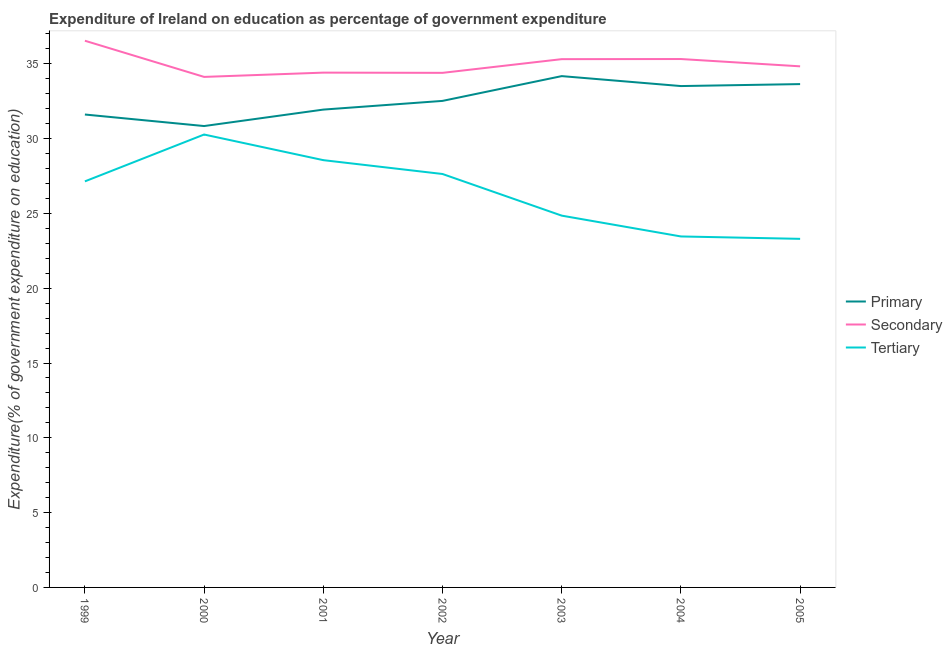Does the line corresponding to expenditure on secondary education intersect with the line corresponding to expenditure on primary education?
Provide a succinct answer. No. What is the expenditure on primary education in 2005?
Ensure brevity in your answer.  33.65. Across all years, what is the maximum expenditure on secondary education?
Offer a terse response. 36.54. Across all years, what is the minimum expenditure on primary education?
Offer a terse response. 30.84. In which year was the expenditure on primary education minimum?
Offer a terse response. 2000. What is the total expenditure on tertiary education in the graph?
Provide a succinct answer. 185.23. What is the difference between the expenditure on tertiary education in 1999 and that in 2004?
Ensure brevity in your answer.  3.68. What is the difference between the expenditure on secondary education in 2004 and the expenditure on tertiary education in 2001?
Your answer should be compact. 6.76. What is the average expenditure on primary education per year?
Provide a short and direct response. 32.61. In the year 2003, what is the difference between the expenditure on secondary education and expenditure on tertiary education?
Keep it short and to the point. 10.46. In how many years, is the expenditure on primary education greater than 11 %?
Provide a succinct answer. 7. What is the ratio of the expenditure on primary education in 2001 to that in 2004?
Ensure brevity in your answer.  0.95. Is the expenditure on secondary education in 2000 less than that in 2002?
Make the answer very short. Yes. Is the difference between the expenditure on tertiary education in 1999 and 2001 greater than the difference between the expenditure on primary education in 1999 and 2001?
Offer a very short reply. No. What is the difference between the highest and the second highest expenditure on primary education?
Offer a terse response. 0.53. What is the difference between the highest and the lowest expenditure on secondary education?
Your response must be concise. 2.42. Is the sum of the expenditure on primary education in 2000 and 2004 greater than the maximum expenditure on tertiary education across all years?
Your answer should be compact. Yes. How many lines are there?
Your answer should be compact. 3. What is the difference between two consecutive major ticks on the Y-axis?
Ensure brevity in your answer.  5. Where does the legend appear in the graph?
Provide a short and direct response. Center right. How are the legend labels stacked?
Ensure brevity in your answer.  Vertical. What is the title of the graph?
Your response must be concise. Expenditure of Ireland on education as percentage of government expenditure. Does "Ages 0-14" appear as one of the legend labels in the graph?
Your response must be concise. No. What is the label or title of the X-axis?
Offer a very short reply. Year. What is the label or title of the Y-axis?
Provide a short and direct response. Expenditure(% of government expenditure on education). What is the Expenditure(% of government expenditure on education) in Primary in 1999?
Offer a very short reply. 31.61. What is the Expenditure(% of government expenditure on education) of Secondary in 1999?
Keep it short and to the point. 36.54. What is the Expenditure(% of government expenditure on education) in Tertiary in 1999?
Provide a succinct answer. 27.14. What is the Expenditure(% of government expenditure on education) in Primary in 2000?
Ensure brevity in your answer.  30.84. What is the Expenditure(% of government expenditure on education) of Secondary in 2000?
Your answer should be compact. 34.13. What is the Expenditure(% of government expenditure on education) in Tertiary in 2000?
Your answer should be very brief. 30.27. What is the Expenditure(% of government expenditure on education) of Primary in 2001?
Offer a very short reply. 31.94. What is the Expenditure(% of government expenditure on education) in Secondary in 2001?
Your answer should be very brief. 34.41. What is the Expenditure(% of government expenditure on education) in Tertiary in 2001?
Ensure brevity in your answer.  28.56. What is the Expenditure(% of government expenditure on education) in Primary in 2002?
Make the answer very short. 32.52. What is the Expenditure(% of government expenditure on education) of Secondary in 2002?
Your answer should be very brief. 34.4. What is the Expenditure(% of government expenditure on education) of Tertiary in 2002?
Give a very brief answer. 27.64. What is the Expenditure(% of government expenditure on education) in Primary in 2003?
Keep it short and to the point. 34.18. What is the Expenditure(% of government expenditure on education) of Secondary in 2003?
Give a very brief answer. 35.31. What is the Expenditure(% of government expenditure on education) in Tertiary in 2003?
Provide a short and direct response. 24.85. What is the Expenditure(% of government expenditure on education) of Primary in 2004?
Offer a very short reply. 33.51. What is the Expenditure(% of government expenditure on education) of Secondary in 2004?
Offer a terse response. 35.32. What is the Expenditure(% of government expenditure on education) in Tertiary in 2004?
Provide a succinct answer. 23.46. What is the Expenditure(% of government expenditure on education) in Primary in 2005?
Keep it short and to the point. 33.65. What is the Expenditure(% of government expenditure on education) of Secondary in 2005?
Offer a very short reply. 34.83. What is the Expenditure(% of government expenditure on education) of Tertiary in 2005?
Provide a succinct answer. 23.3. Across all years, what is the maximum Expenditure(% of government expenditure on education) of Primary?
Your answer should be very brief. 34.18. Across all years, what is the maximum Expenditure(% of government expenditure on education) of Secondary?
Provide a succinct answer. 36.54. Across all years, what is the maximum Expenditure(% of government expenditure on education) of Tertiary?
Keep it short and to the point. 30.27. Across all years, what is the minimum Expenditure(% of government expenditure on education) in Primary?
Offer a terse response. 30.84. Across all years, what is the minimum Expenditure(% of government expenditure on education) of Secondary?
Provide a succinct answer. 34.13. Across all years, what is the minimum Expenditure(% of government expenditure on education) in Tertiary?
Offer a very short reply. 23.3. What is the total Expenditure(% of government expenditure on education) of Primary in the graph?
Offer a terse response. 228.25. What is the total Expenditure(% of government expenditure on education) of Secondary in the graph?
Give a very brief answer. 244.95. What is the total Expenditure(% of government expenditure on education) of Tertiary in the graph?
Your answer should be very brief. 185.23. What is the difference between the Expenditure(% of government expenditure on education) of Primary in 1999 and that in 2000?
Provide a short and direct response. 0.77. What is the difference between the Expenditure(% of government expenditure on education) in Secondary in 1999 and that in 2000?
Your response must be concise. 2.42. What is the difference between the Expenditure(% of government expenditure on education) in Tertiary in 1999 and that in 2000?
Offer a very short reply. -3.13. What is the difference between the Expenditure(% of government expenditure on education) of Primary in 1999 and that in 2001?
Offer a very short reply. -0.33. What is the difference between the Expenditure(% of government expenditure on education) in Secondary in 1999 and that in 2001?
Offer a very short reply. 2.13. What is the difference between the Expenditure(% of government expenditure on education) in Tertiary in 1999 and that in 2001?
Your answer should be compact. -1.42. What is the difference between the Expenditure(% of government expenditure on education) of Primary in 1999 and that in 2002?
Make the answer very short. -0.91. What is the difference between the Expenditure(% of government expenditure on education) in Secondary in 1999 and that in 2002?
Your answer should be compact. 2.15. What is the difference between the Expenditure(% of government expenditure on education) of Tertiary in 1999 and that in 2002?
Your answer should be very brief. -0.49. What is the difference between the Expenditure(% of government expenditure on education) of Primary in 1999 and that in 2003?
Ensure brevity in your answer.  -2.57. What is the difference between the Expenditure(% of government expenditure on education) of Secondary in 1999 and that in 2003?
Ensure brevity in your answer.  1.23. What is the difference between the Expenditure(% of government expenditure on education) in Tertiary in 1999 and that in 2003?
Your answer should be compact. 2.29. What is the difference between the Expenditure(% of government expenditure on education) of Primary in 1999 and that in 2004?
Provide a short and direct response. -1.9. What is the difference between the Expenditure(% of government expenditure on education) of Secondary in 1999 and that in 2004?
Your answer should be very brief. 1.22. What is the difference between the Expenditure(% of government expenditure on education) in Tertiary in 1999 and that in 2004?
Provide a succinct answer. 3.68. What is the difference between the Expenditure(% of government expenditure on education) of Primary in 1999 and that in 2005?
Make the answer very short. -2.03. What is the difference between the Expenditure(% of government expenditure on education) in Secondary in 1999 and that in 2005?
Ensure brevity in your answer.  1.71. What is the difference between the Expenditure(% of government expenditure on education) in Tertiary in 1999 and that in 2005?
Keep it short and to the point. 3.84. What is the difference between the Expenditure(% of government expenditure on education) of Primary in 2000 and that in 2001?
Ensure brevity in your answer.  -1.1. What is the difference between the Expenditure(% of government expenditure on education) of Secondary in 2000 and that in 2001?
Provide a short and direct response. -0.29. What is the difference between the Expenditure(% of government expenditure on education) in Tertiary in 2000 and that in 2001?
Make the answer very short. 1.71. What is the difference between the Expenditure(% of government expenditure on education) of Primary in 2000 and that in 2002?
Provide a succinct answer. -1.68. What is the difference between the Expenditure(% of government expenditure on education) in Secondary in 2000 and that in 2002?
Offer a very short reply. -0.27. What is the difference between the Expenditure(% of government expenditure on education) in Tertiary in 2000 and that in 2002?
Give a very brief answer. 2.64. What is the difference between the Expenditure(% of government expenditure on education) in Primary in 2000 and that in 2003?
Ensure brevity in your answer.  -3.34. What is the difference between the Expenditure(% of government expenditure on education) in Secondary in 2000 and that in 2003?
Make the answer very short. -1.19. What is the difference between the Expenditure(% of government expenditure on education) of Tertiary in 2000 and that in 2003?
Provide a succinct answer. 5.42. What is the difference between the Expenditure(% of government expenditure on education) in Primary in 2000 and that in 2004?
Make the answer very short. -2.67. What is the difference between the Expenditure(% of government expenditure on education) of Secondary in 2000 and that in 2004?
Offer a very short reply. -1.19. What is the difference between the Expenditure(% of government expenditure on education) of Tertiary in 2000 and that in 2004?
Provide a succinct answer. 6.81. What is the difference between the Expenditure(% of government expenditure on education) of Primary in 2000 and that in 2005?
Keep it short and to the point. -2.81. What is the difference between the Expenditure(% of government expenditure on education) in Secondary in 2000 and that in 2005?
Keep it short and to the point. -0.71. What is the difference between the Expenditure(% of government expenditure on education) of Tertiary in 2000 and that in 2005?
Keep it short and to the point. 6.97. What is the difference between the Expenditure(% of government expenditure on education) in Primary in 2001 and that in 2002?
Make the answer very short. -0.58. What is the difference between the Expenditure(% of government expenditure on education) in Secondary in 2001 and that in 2002?
Your answer should be compact. 0.02. What is the difference between the Expenditure(% of government expenditure on education) in Tertiary in 2001 and that in 2002?
Provide a short and direct response. 0.93. What is the difference between the Expenditure(% of government expenditure on education) in Primary in 2001 and that in 2003?
Your response must be concise. -2.24. What is the difference between the Expenditure(% of government expenditure on education) of Secondary in 2001 and that in 2003?
Provide a succinct answer. -0.9. What is the difference between the Expenditure(% of government expenditure on education) of Tertiary in 2001 and that in 2003?
Ensure brevity in your answer.  3.71. What is the difference between the Expenditure(% of government expenditure on education) in Primary in 2001 and that in 2004?
Keep it short and to the point. -1.57. What is the difference between the Expenditure(% of government expenditure on education) in Secondary in 2001 and that in 2004?
Offer a very short reply. -0.91. What is the difference between the Expenditure(% of government expenditure on education) in Tertiary in 2001 and that in 2004?
Give a very brief answer. 5.1. What is the difference between the Expenditure(% of government expenditure on education) in Primary in 2001 and that in 2005?
Make the answer very short. -1.71. What is the difference between the Expenditure(% of government expenditure on education) of Secondary in 2001 and that in 2005?
Your answer should be very brief. -0.42. What is the difference between the Expenditure(% of government expenditure on education) in Tertiary in 2001 and that in 2005?
Your response must be concise. 5.26. What is the difference between the Expenditure(% of government expenditure on education) in Primary in 2002 and that in 2003?
Your answer should be compact. -1.66. What is the difference between the Expenditure(% of government expenditure on education) of Secondary in 2002 and that in 2003?
Provide a succinct answer. -0.92. What is the difference between the Expenditure(% of government expenditure on education) of Tertiary in 2002 and that in 2003?
Your answer should be compact. 2.78. What is the difference between the Expenditure(% of government expenditure on education) of Primary in 2002 and that in 2004?
Offer a terse response. -0.99. What is the difference between the Expenditure(% of government expenditure on education) in Secondary in 2002 and that in 2004?
Offer a very short reply. -0.92. What is the difference between the Expenditure(% of government expenditure on education) of Tertiary in 2002 and that in 2004?
Keep it short and to the point. 4.18. What is the difference between the Expenditure(% of government expenditure on education) in Primary in 2002 and that in 2005?
Ensure brevity in your answer.  -1.12. What is the difference between the Expenditure(% of government expenditure on education) in Secondary in 2002 and that in 2005?
Ensure brevity in your answer.  -0.44. What is the difference between the Expenditure(% of government expenditure on education) of Tertiary in 2002 and that in 2005?
Offer a very short reply. 4.34. What is the difference between the Expenditure(% of government expenditure on education) in Primary in 2003 and that in 2004?
Offer a terse response. 0.66. What is the difference between the Expenditure(% of government expenditure on education) of Secondary in 2003 and that in 2004?
Provide a short and direct response. -0.01. What is the difference between the Expenditure(% of government expenditure on education) in Tertiary in 2003 and that in 2004?
Keep it short and to the point. 1.39. What is the difference between the Expenditure(% of government expenditure on education) of Primary in 2003 and that in 2005?
Your answer should be compact. 0.53. What is the difference between the Expenditure(% of government expenditure on education) of Secondary in 2003 and that in 2005?
Offer a terse response. 0.48. What is the difference between the Expenditure(% of government expenditure on education) of Tertiary in 2003 and that in 2005?
Ensure brevity in your answer.  1.55. What is the difference between the Expenditure(% of government expenditure on education) of Primary in 2004 and that in 2005?
Make the answer very short. -0.13. What is the difference between the Expenditure(% of government expenditure on education) of Secondary in 2004 and that in 2005?
Make the answer very short. 0.49. What is the difference between the Expenditure(% of government expenditure on education) in Tertiary in 2004 and that in 2005?
Your answer should be compact. 0.16. What is the difference between the Expenditure(% of government expenditure on education) of Primary in 1999 and the Expenditure(% of government expenditure on education) of Secondary in 2000?
Offer a terse response. -2.51. What is the difference between the Expenditure(% of government expenditure on education) of Primary in 1999 and the Expenditure(% of government expenditure on education) of Tertiary in 2000?
Your response must be concise. 1.34. What is the difference between the Expenditure(% of government expenditure on education) in Secondary in 1999 and the Expenditure(% of government expenditure on education) in Tertiary in 2000?
Provide a short and direct response. 6.27. What is the difference between the Expenditure(% of government expenditure on education) in Primary in 1999 and the Expenditure(% of government expenditure on education) in Secondary in 2001?
Offer a very short reply. -2.8. What is the difference between the Expenditure(% of government expenditure on education) in Primary in 1999 and the Expenditure(% of government expenditure on education) in Tertiary in 2001?
Keep it short and to the point. 3.05. What is the difference between the Expenditure(% of government expenditure on education) in Secondary in 1999 and the Expenditure(% of government expenditure on education) in Tertiary in 2001?
Offer a very short reply. 7.98. What is the difference between the Expenditure(% of government expenditure on education) of Primary in 1999 and the Expenditure(% of government expenditure on education) of Secondary in 2002?
Keep it short and to the point. -2.79. What is the difference between the Expenditure(% of government expenditure on education) in Primary in 1999 and the Expenditure(% of government expenditure on education) in Tertiary in 2002?
Your answer should be very brief. 3.98. What is the difference between the Expenditure(% of government expenditure on education) of Secondary in 1999 and the Expenditure(% of government expenditure on education) of Tertiary in 2002?
Offer a very short reply. 8.91. What is the difference between the Expenditure(% of government expenditure on education) of Primary in 1999 and the Expenditure(% of government expenditure on education) of Secondary in 2003?
Provide a short and direct response. -3.7. What is the difference between the Expenditure(% of government expenditure on education) in Primary in 1999 and the Expenditure(% of government expenditure on education) in Tertiary in 2003?
Provide a short and direct response. 6.76. What is the difference between the Expenditure(% of government expenditure on education) in Secondary in 1999 and the Expenditure(% of government expenditure on education) in Tertiary in 2003?
Your answer should be very brief. 11.69. What is the difference between the Expenditure(% of government expenditure on education) in Primary in 1999 and the Expenditure(% of government expenditure on education) in Secondary in 2004?
Offer a very short reply. -3.71. What is the difference between the Expenditure(% of government expenditure on education) of Primary in 1999 and the Expenditure(% of government expenditure on education) of Tertiary in 2004?
Keep it short and to the point. 8.15. What is the difference between the Expenditure(% of government expenditure on education) of Secondary in 1999 and the Expenditure(% of government expenditure on education) of Tertiary in 2004?
Offer a terse response. 13.08. What is the difference between the Expenditure(% of government expenditure on education) in Primary in 1999 and the Expenditure(% of government expenditure on education) in Secondary in 2005?
Ensure brevity in your answer.  -3.22. What is the difference between the Expenditure(% of government expenditure on education) of Primary in 1999 and the Expenditure(% of government expenditure on education) of Tertiary in 2005?
Keep it short and to the point. 8.31. What is the difference between the Expenditure(% of government expenditure on education) in Secondary in 1999 and the Expenditure(% of government expenditure on education) in Tertiary in 2005?
Ensure brevity in your answer.  13.24. What is the difference between the Expenditure(% of government expenditure on education) in Primary in 2000 and the Expenditure(% of government expenditure on education) in Secondary in 2001?
Your response must be concise. -3.57. What is the difference between the Expenditure(% of government expenditure on education) of Primary in 2000 and the Expenditure(% of government expenditure on education) of Tertiary in 2001?
Give a very brief answer. 2.28. What is the difference between the Expenditure(% of government expenditure on education) in Secondary in 2000 and the Expenditure(% of government expenditure on education) in Tertiary in 2001?
Give a very brief answer. 5.57. What is the difference between the Expenditure(% of government expenditure on education) in Primary in 2000 and the Expenditure(% of government expenditure on education) in Secondary in 2002?
Offer a terse response. -3.56. What is the difference between the Expenditure(% of government expenditure on education) in Primary in 2000 and the Expenditure(% of government expenditure on education) in Tertiary in 2002?
Your response must be concise. 3.2. What is the difference between the Expenditure(% of government expenditure on education) of Secondary in 2000 and the Expenditure(% of government expenditure on education) of Tertiary in 2002?
Ensure brevity in your answer.  6.49. What is the difference between the Expenditure(% of government expenditure on education) of Primary in 2000 and the Expenditure(% of government expenditure on education) of Secondary in 2003?
Your answer should be compact. -4.47. What is the difference between the Expenditure(% of government expenditure on education) of Primary in 2000 and the Expenditure(% of government expenditure on education) of Tertiary in 2003?
Make the answer very short. 5.99. What is the difference between the Expenditure(% of government expenditure on education) in Secondary in 2000 and the Expenditure(% of government expenditure on education) in Tertiary in 2003?
Ensure brevity in your answer.  9.27. What is the difference between the Expenditure(% of government expenditure on education) of Primary in 2000 and the Expenditure(% of government expenditure on education) of Secondary in 2004?
Provide a succinct answer. -4.48. What is the difference between the Expenditure(% of government expenditure on education) in Primary in 2000 and the Expenditure(% of government expenditure on education) in Tertiary in 2004?
Give a very brief answer. 7.38. What is the difference between the Expenditure(% of government expenditure on education) of Secondary in 2000 and the Expenditure(% of government expenditure on education) of Tertiary in 2004?
Your answer should be very brief. 10.67. What is the difference between the Expenditure(% of government expenditure on education) in Primary in 2000 and the Expenditure(% of government expenditure on education) in Secondary in 2005?
Your response must be concise. -3.99. What is the difference between the Expenditure(% of government expenditure on education) of Primary in 2000 and the Expenditure(% of government expenditure on education) of Tertiary in 2005?
Your response must be concise. 7.54. What is the difference between the Expenditure(% of government expenditure on education) of Secondary in 2000 and the Expenditure(% of government expenditure on education) of Tertiary in 2005?
Offer a very short reply. 10.83. What is the difference between the Expenditure(% of government expenditure on education) in Primary in 2001 and the Expenditure(% of government expenditure on education) in Secondary in 2002?
Give a very brief answer. -2.46. What is the difference between the Expenditure(% of government expenditure on education) of Primary in 2001 and the Expenditure(% of government expenditure on education) of Tertiary in 2002?
Your answer should be compact. 4.3. What is the difference between the Expenditure(% of government expenditure on education) of Secondary in 2001 and the Expenditure(% of government expenditure on education) of Tertiary in 2002?
Your response must be concise. 6.78. What is the difference between the Expenditure(% of government expenditure on education) of Primary in 2001 and the Expenditure(% of government expenditure on education) of Secondary in 2003?
Your response must be concise. -3.37. What is the difference between the Expenditure(% of government expenditure on education) of Primary in 2001 and the Expenditure(% of government expenditure on education) of Tertiary in 2003?
Provide a short and direct response. 7.09. What is the difference between the Expenditure(% of government expenditure on education) in Secondary in 2001 and the Expenditure(% of government expenditure on education) in Tertiary in 2003?
Give a very brief answer. 9.56. What is the difference between the Expenditure(% of government expenditure on education) of Primary in 2001 and the Expenditure(% of government expenditure on education) of Secondary in 2004?
Offer a terse response. -3.38. What is the difference between the Expenditure(% of government expenditure on education) in Primary in 2001 and the Expenditure(% of government expenditure on education) in Tertiary in 2004?
Give a very brief answer. 8.48. What is the difference between the Expenditure(% of government expenditure on education) in Secondary in 2001 and the Expenditure(% of government expenditure on education) in Tertiary in 2004?
Provide a short and direct response. 10.95. What is the difference between the Expenditure(% of government expenditure on education) in Primary in 2001 and the Expenditure(% of government expenditure on education) in Secondary in 2005?
Offer a very short reply. -2.89. What is the difference between the Expenditure(% of government expenditure on education) in Primary in 2001 and the Expenditure(% of government expenditure on education) in Tertiary in 2005?
Give a very brief answer. 8.64. What is the difference between the Expenditure(% of government expenditure on education) in Secondary in 2001 and the Expenditure(% of government expenditure on education) in Tertiary in 2005?
Provide a succinct answer. 11.11. What is the difference between the Expenditure(% of government expenditure on education) in Primary in 2002 and the Expenditure(% of government expenditure on education) in Secondary in 2003?
Give a very brief answer. -2.79. What is the difference between the Expenditure(% of government expenditure on education) of Primary in 2002 and the Expenditure(% of government expenditure on education) of Tertiary in 2003?
Ensure brevity in your answer.  7.67. What is the difference between the Expenditure(% of government expenditure on education) in Secondary in 2002 and the Expenditure(% of government expenditure on education) in Tertiary in 2003?
Keep it short and to the point. 9.54. What is the difference between the Expenditure(% of government expenditure on education) in Primary in 2002 and the Expenditure(% of government expenditure on education) in Secondary in 2004?
Provide a succinct answer. -2.8. What is the difference between the Expenditure(% of government expenditure on education) in Primary in 2002 and the Expenditure(% of government expenditure on education) in Tertiary in 2004?
Offer a terse response. 9.06. What is the difference between the Expenditure(% of government expenditure on education) of Secondary in 2002 and the Expenditure(% of government expenditure on education) of Tertiary in 2004?
Provide a short and direct response. 10.94. What is the difference between the Expenditure(% of government expenditure on education) in Primary in 2002 and the Expenditure(% of government expenditure on education) in Secondary in 2005?
Provide a succinct answer. -2.31. What is the difference between the Expenditure(% of government expenditure on education) of Primary in 2002 and the Expenditure(% of government expenditure on education) of Tertiary in 2005?
Your answer should be compact. 9.22. What is the difference between the Expenditure(% of government expenditure on education) of Secondary in 2002 and the Expenditure(% of government expenditure on education) of Tertiary in 2005?
Offer a terse response. 11.1. What is the difference between the Expenditure(% of government expenditure on education) in Primary in 2003 and the Expenditure(% of government expenditure on education) in Secondary in 2004?
Your answer should be compact. -1.14. What is the difference between the Expenditure(% of government expenditure on education) in Primary in 2003 and the Expenditure(% of government expenditure on education) in Tertiary in 2004?
Offer a terse response. 10.72. What is the difference between the Expenditure(% of government expenditure on education) in Secondary in 2003 and the Expenditure(% of government expenditure on education) in Tertiary in 2004?
Provide a succinct answer. 11.85. What is the difference between the Expenditure(% of government expenditure on education) of Primary in 2003 and the Expenditure(% of government expenditure on education) of Secondary in 2005?
Make the answer very short. -0.65. What is the difference between the Expenditure(% of government expenditure on education) of Primary in 2003 and the Expenditure(% of government expenditure on education) of Tertiary in 2005?
Ensure brevity in your answer.  10.88. What is the difference between the Expenditure(% of government expenditure on education) of Secondary in 2003 and the Expenditure(% of government expenditure on education) of Tertiary in 2005?
Your answer should be compact. 12.01. What is the difference between the Expenditure(% of government expenditure on education) in Primary in 2004 and the Expenditure(% of government expenditure on education) in Secondary in 2005?
Your answer should be very brief. -1.32. What is the difference between the Expenditure(% of government expenditure on education) in Primary in 2004 and the Expenditure(% of government expenditure on education) in Tertiary in 2005?
Make the answer very short. 10.21. What is the difference between the Expenditure(% of government expenditure on education) in Secondary in 2004 and the Expenditure(% of government expenditure on education) in Tertiary in 2005?
Give a very brief answer. 12.02. What is the average Expenditure(% of government expenditure on education) of Primary per year?
Provide a succinct answer. 32.61. What is the average Expenditure(% of government expenditure on education) in Secondary per year?
Your response must be concise. 34.99. What is the average Expenditure(% of government expenditure on education) in Tertiary per year?
Keep it short and to the point. 26.46. In the year 1999, what is the difference between the Expenditure(% of government expenditure on education) of Primary and Expenditure(% of government expenditure on education) of Secondary?
Your answer should be very brief. -4.93. In the year 1999, what is the difference between the Expenditure(% of government expenditure on education) in Primary and Expenditure(% of government expenditure on education) in Tertiary?
Give a very brief answer. 4.47. In the year 1999, what is the difference between the Expenditure(% of government expenditure on education) of Secondary and Expenditure(% of government expenditure on education) of Tertiary?
Your answer should be very brief. 9.4. In the year 2000, what is the difference between the Expenditure(% of government expenditure on education) in Primary and Expenditure(% of government expenditure on education) in Secondary?
Your response must be concise. -3.29. In the year 2000, what is the difference between the Expenditure(% of government expenditure on education) in Primary and Expenditure(% of government expenditure on education) in Tertiary?
Ensure brevity in your answer.  0.57. In the year 2000, what is the difference between the Expenditure(% of government expenditure on education) of Secondary and Expenditure(% of government expenditure on education) of Tertiary?
Ensure brevity in your answer.  3.85. In the year 2001, what is the difference between the Expenditure(% of government expenditure on education) of Primary and Expenditure(% of government expenditure on education) of Secondary?
Make the answer very short. -2.47. In the year 2001, what is the difference between the Expenditure(% of government expenditure on education) in Primary and Expenditure(% of government expenditure on education) in Tertiary?
Provide a short and direct response. 3.38. In the year 2001, what is the difference between the Expenditure(% of government expenditure on education) in Secondary and Expenditure(% of government expenditure on education) in Tertiary?
Offer a terse response. 5.85. In the year 2002, what is the difference between the Expenditure(% of government expenditure on education) of Primary and Expenditure(% of government expenditure on education) of Secondary?
Keep it short and to the point. -1.88. In the year 2002, what is the difference between the Expenditure(% of government expenditure on education) in Primary and Expenditure(% of government expenditure on education) in Tertiary?
Your answer should be very brief. 4.89. In the year 2002, what is the difference between the Expenditure(% of government expenditure on education) of Secondary and Expenditure(% of government expenditure on education) of Tertiary?
Offer a very short reply. 6.76. In the year 2003, what is the difference between the Expenditure(% of government expenditure on education) in Primary and Expenditure(% of government expenditure on education) in Secondary?
Ensure brevity in your answer.  -1.13. In the year 2003, what is the difference between the Expenditure(% of government expenditure on education) of Primary and Expenditure(% of government expenditure on education) of Tertiary?
Your answer should be compact. 9.33. In the year 2003, what is the difference between the Expenditure(% of government expenditure on education) in Secondary and Expenditure(% of government expenditure on education) in Tertiary?
Your answer should be very brief. 10.46. In the year 2004, what is the difference between the Expenditure(% of government expenditure on education) of Primary and Expenditure(% of government expenditure on education) of Secondary?
Offer a very short reply. -1.81. In the year 2004, what is the difference between the Expenditure(% of government expenditure on education) in Primary and Expenditure(% of government expenditure on education) in Tertiary?
Give a very brief answer. 10.05. In the year 2004, what is the difference between the Expenditure(% of government expenditure on education) of Secondary and Expenditure(% of government expenditure on education) of Tertiary?
Offer a very short reply. 11.86. In the year 2005, what is the difference between the Expenditure(% of government expenditure on education) in Primary and Expenditure(% of government expenditure on education) in Secondary?
Make the answer very short. -1.19. In the year 2005, what is the difference between the Expenditure(% of government expenditure on education) of Primary and Expenditure(% of government expenditure on education) of Tertiary?
Ensure brevity in your answer.  10.35. In the year 2005, what is the difference between the Expenditure(% of government expenditure on education) in Secondary and Expenditure(% of government expenditure on education) in Tertiary?
Your answer should be compact. 11.53. What is the ratio of the Expenditure(% of government expenditure on education) in Primary in 1999 to that in 2000?
Offer a very short reply. 1.02. What is the ratio of the Expenditure(% of government expenditure on education) in Secondary in 1999 to that in 2000?
Offer a terse response. 1.07. What is the ratio of the Expenditure(% of government expenditure on education) in Tertiary in 1999 to that in 2000?
Your answer should be compact. 0.9. What is the ratio of the Expenditure(% of government expenditure on education) of Primary in 1999 to that in 2001?
Give a very brief answer. 0.99. What is the ratio of the Expenditure(% of government expenditure on education) of Secondary in 1999 to that in 2001?
Offer a terse response. 1.06. What is the ratio of the Expenditure(% of government expenditure on education) of Tertiary in 1999 to that in 2001?
Your response must be concise. 0.95. What is the ratio of the Expenditure(% of government expenditure on education) of Secondary in 1999 to that in 2002?
Keep it short and to the point. 1.06. What is the ratio of the Expenditure(% of government expenditure on education) of Tertiary in 1999 to that in 2002?
Provide a succinct answer. 0.98. What is the ratio of the Expenditure(% of government expenditure on education) of Primary in 1999 to that in 2003?
Ensure brevity in your answer.  0.92. What is the ratio of the Expenditure(% of government expenditure on education) of Secondary in 1999 to that in 2003?
Your answer should be very brief. 1.03. What is the ratio of the Expenditure(% of government expenditure on education) of Tertiary in 1999 to that in 2003?
Your answer should be compact. 1.09. What is the ratio of the Expenditure(% of government expenditure on education) of Primary in 1999 to that in 2004?
Ensure brevity in your answer.  0.94. What is the ratio of the Expenditure(% of government expenditure on education) in Secondary in 1999 to that in 2004?
Keep it short and to the point. 1.03. What is the ratio of the Expenditure(% of government expenditure on education) of Tertiary in 1999 to that in 2004?
Offer a very short reply. 1.16. What is the ratio of the Expenditure(% of government expenditure on education) of Primary in 1999 to that in 2005?
Keep it short and to the point. 0.94. What is the ratio of the Expenditure(% of government expenditure on education) in Secondary in 1999 to that in 2005?
Offer a very short reply. 1.05. What is the ratio of the Expenditure(% of government expenditure on education) in Tertiary in 1999 to that in 2005?
Provide a short and direct response. 1.16. What is the ratio of the Expenditure(% of government expenditure on education) of Primary in 2000 to that in 2001?
Ensure brevity in your answer.  0.97. What is the ratio of the Expenditure(% of government expenditure on education) of Secondary in 2000 to that in 2001?
Your answer should be very brief. 0.99. What is the ratio of the Expenditure(% of government expenditure on education) of Tertiary in 2000 to that in 2001?
Make the answer very short. 1.06. What is the ratio of the Expenditure(% of government expenditure on education) of Primary in 2000 to that in 2002?
Your answer should be very brief. 0.95. What is the ratio of the Expenditure(% of government expenditure on education) in Secondary in 2000 to that in 2002?
Ensure brevity in your answer.  0.99. What is the ratio of the Expenditure(% of government expenditure on education) in Tertiary in 2000 to that in 2002?
Provide a succinct answer. 1.1. What is the ratio of the Expenditure(% of government expenditure on education) of Primary in 2000 to that in 2003?
Provide a short and direct response. 0.9. What is the ratio of the Expenditure(% of government expenditure on education) in Secondary in 2000 to that in 2003?
Ensure brevity in your answer.  0.97. What is the ratio of the Expenditure(% of government expenditure on education) of Tertiary in 2000 to that in 2003?
Your response must be concise. 1.22. What is the ratio of the Expenditure(% of government expenditure on education) of Primary in 2000 to that in 2004?
Make the answer very short. 0.92. What is the ratio of the Expenditure(% of government expenditure on education) of Secondary in 2000 to that in 2004?
Your answer should be very brief. 0.97. What is the ratio of the Expenditure(% of government expenditure on education) in Tertiary in 2000 to that in 2004?
Keep it short and to the point. 1.29. What is the ratio of the Expenditure(% of government expenditure on education) of Primary in 2000 to that in 2005?
Keep it short and to the point. 0.92. What is the ratio of the Expenditure(% of government expenditure on education) of Secondary in 2000 to that in 2005?
Provide a succinct answer. 0.98. What is the ratio of the Expenditure(% of government expenditure on education) of Tertiary in 2000 to that in 2005?
Ensure brevity in your answer.  1.3. What is the ratio of the Expenditure(% of government expenditure on education) of Primary in 2001 to that in 2002?
Provide a succinct answer. 0.98. What is the ratio of the Expenditure(% of government expenditure on education) in Secondary in 2001 to that in 2002?
Keep it short and to the point. 1. What is the ratio of the Expenditure(% of government expenditure on education) in Tertiary in 2001 to that in 2002?
Offer a terse response. 1.03. What is the ratio of the Expenditure(% of government expenditure on education) in Primary in 2001 to that in 2003?
Offer a terse response. 0.93. What is the ratio of the Expenditure(% of government expenditure on education) in Secondary in 2001 to that in 2003?
Provide a succinct answer. 0.97. What is the ratio of the Expenditure(% of government expenditure on education) of Tertiary in 2001 to that in 2003?
Keep it short and to the point. 1.15. What is the ratio of the Expenditure(% of government expenditure on education) in Primary in 2001 to that in 2004?
Offer a terse response. 0.95. What is the ratio of the Expenditure(% of government expenditure on education) of Secondary in 2001 to that in 2004?
Ensure brevity in your answer.  0.97. What is the ratio of the Expenditure(% of government expenditure on education) in Tertiary in 2001 to that in 2004?
Provide a short and direct response. 1.22. What is the ratio of the Expenditure(% of government expenditure on education) of Primary in 2001 to that in 2005?
Your answer should be very brief. 0.95. What is the ratio of the Expenditure(% of government expenditure on education) in Secondary in 2001 to that in 2005?
Provide a succinct answer. 0.99. What is the ratio of the Expenditure(% of government expenditure on education) in Tertiary in 2001 to that in 2005?
Your answer should be compact. 1.23. What is the ratio of the Expenditure(% of government expenditure on education) of Primary in 2002 to that in 2003?
Offer a very short reply. 0.95. What is the ratio of the Expenditure(% of government expenditure on education) of Secondary in 2002 to that in 2003?
Ensure brevity in your answer.  0.97. What is the ratio of the Expenditure(% of government expenditure on education) of Tertiary in 2002 to that in 2003?
Your answer should be compact. 1.11. What is the ratio of the Expenditure(% of government expenditure on education) of Primary in 2002 to that in 2004?
Offer a terse response. 0.97. What is the ratio of the Expenditure(% of government expenditure on education) of Secondary in 2002 to that in 2004?
Offer a terse response. 0.97. What is the ratio of the Expenditure(% of government expenditure on education) of Tertiary in 2002 to that in 2004?
Offer a terse response. 1.18. What is the ratio of the Expenditure(% of government expenditure on education) in Primary in 2002 to that in 2005?
Keep it short and to the point. 0.97. What is the ratio of the Expenditure(% of government expenditure on education) of Secondary in 2002 to that in 2005?
Keep it short and to the point. 0.99. What is the ratio of the Expenditure(% of government expenditure on education) in Tertiary in 2002 to that in 2005?
Your answer should be very brief. 1.19. What is the ratio of the Expenditure(% of government expenditure on education) in Primary in 2003 to that in 2004?
Keep it short and to the point. 1.02. What is the ratio of the Expenditure(% of government expenditure on education) in Tertiary in 2003 to that in 2004?
Provide a succinct answer. 1.06. What is the ratio of the Expenditure(% of government expenditure on education) in Primary in 2003 to that in 2005?
Give a very brief answer. 1.02. What is the ratio of the Expenditure(% of government expenditure on education) of Secondary in 2003 to that in 2005?
Provide a succinct answer. 1.01. What is the ratio of the Expenditure(% of government expenditure on education) in Tertiary in 2003 to that in 2005?
Your answer should be compact. 1.07. What is the ratio of the Expenditure(% of government expenditure on education) of Secondary in 2004 to that in 2005?
Ensure brevity in your answer.  1.01. What is the ratio of the Expenditure(% of government expenditure on education) in Tertiary in 2004 to that in 2005?
Make the answer very short. 1.01. What is the difference between the highest and the second highest Expenditure(% of government expenditure on education) in Primary?
Give a very brief answer. 0.53. What is the difference between the highest and the second highest Expenditure(% of government expenditure on education) of Secondary?
Your answer should be compact. 1.22. What is the difference between the highest and the second highest Expenditure(% of government expenditure on education) of Tertiary?
Your answer should be compact. 1.71. What is the difference between the highest and the lowest Expenditure(% of government expenditure on education) of Primary?
Offer a terse response. 3.34. What is the difference between the highest and the lowest Expenditure(% of government expenditure on education) of Secondary?
Offer a very short reply. 2.42. What is the difference between the highest and the lowest Expenditure(% of government expenditure on education) of Tertiary?
Give a very brief answer. 6.97. 